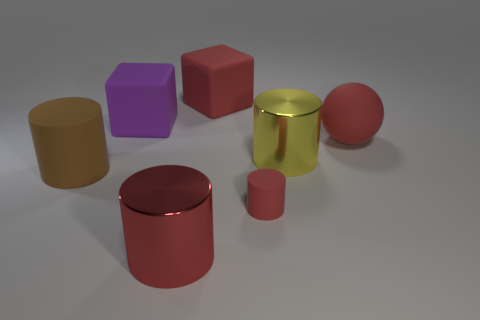Can you describe the spatial arrangement of the objects laid out on the surface? Certainly, there are various geometric solids on a flat surface. On the left, there's a matte yellow cylinder, and moving right, there's a shiny red cylinder and directly in front of it, a small red cylinder. A purple matte cube sits to the right of the red cylinder, closer to us. To the right further back is a reflective yellow cylinder, and in front of it, a pinkish matte sphere. 